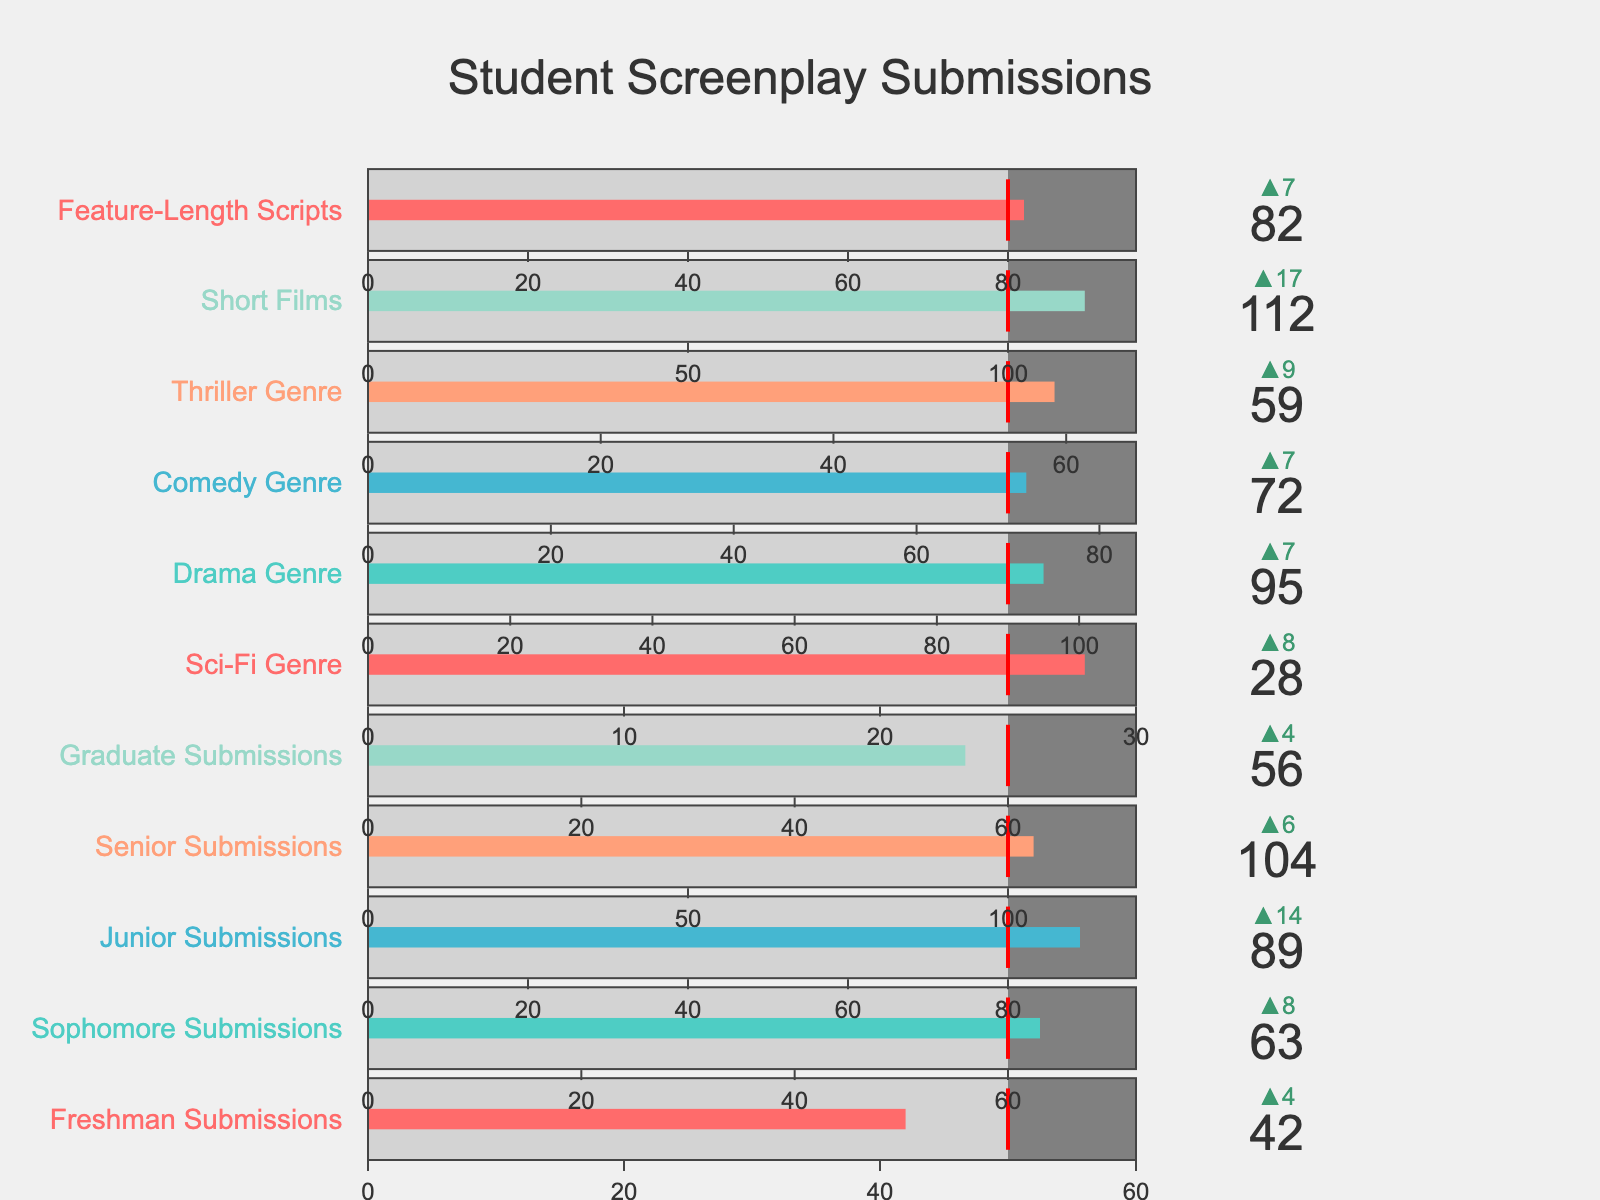What's the title of the figure? The title of the figure is displayed at the top, centered and in large font size, stating the main subject being presented.
Answer: "Student Screenplay Submissions" How many categories are represented in the figure? By counting the number of bullet charts, each representing a different category, we can determine the total number of categories presented.
Answer: 11 Which category had the highest number of submissions this semester? By looking at the actual values in each bullet chart, we compare the numbers to find the highest value.
Answer: Short Films (112) How many categories exceeded their department goals? We can identify if a category exceeded its goal by noting if the actual value indicator surpasses the red threshold line on the bullet chart. Counting these instances gives the result.
Answer: 4 (Junior Submissions, Senior Submissions, Sci-Fi Genre, Short Films) Which genre saw the greatest improvement from the previous year? By examining the delta values on the bullet charts specific to genres, we can find which genre has the largest positive difference when compared to the previous year's submissions.
Answer: Sci-Fi Genre What is the submission goal for Sophomore Submissions? The department goal is indicated by the red threshold line in the bullet chart for Sophomore Submissions.
Answer: 60 What percentage of the goal did Freshman Submissions achieve? Calculate the percentage by dividing the actual number by the goal and then multiplying by 100.
Answer: (42/50) * 100 = 84% Compare the submissions of Comedy Genre and Drama Genre. Which had more and by how much? Look at the actual values for both genres and subtract to find the difference.
Answer: Drama Genre had 23 more (95 - 72) Which category fell short of its previous year's submissions the most? By examining the delta values with negative signs, we can find the category with the largest negative difference.
Answer: Graduate Submissions Which categories did not meet their department goals but had more submissions than the previous year? Identify categories where the actual value is below the red threshold line (goal) but has a positive delta indicating more submissions than the previous year.
Answer: Sophomore Submissions, Thriller Genre 